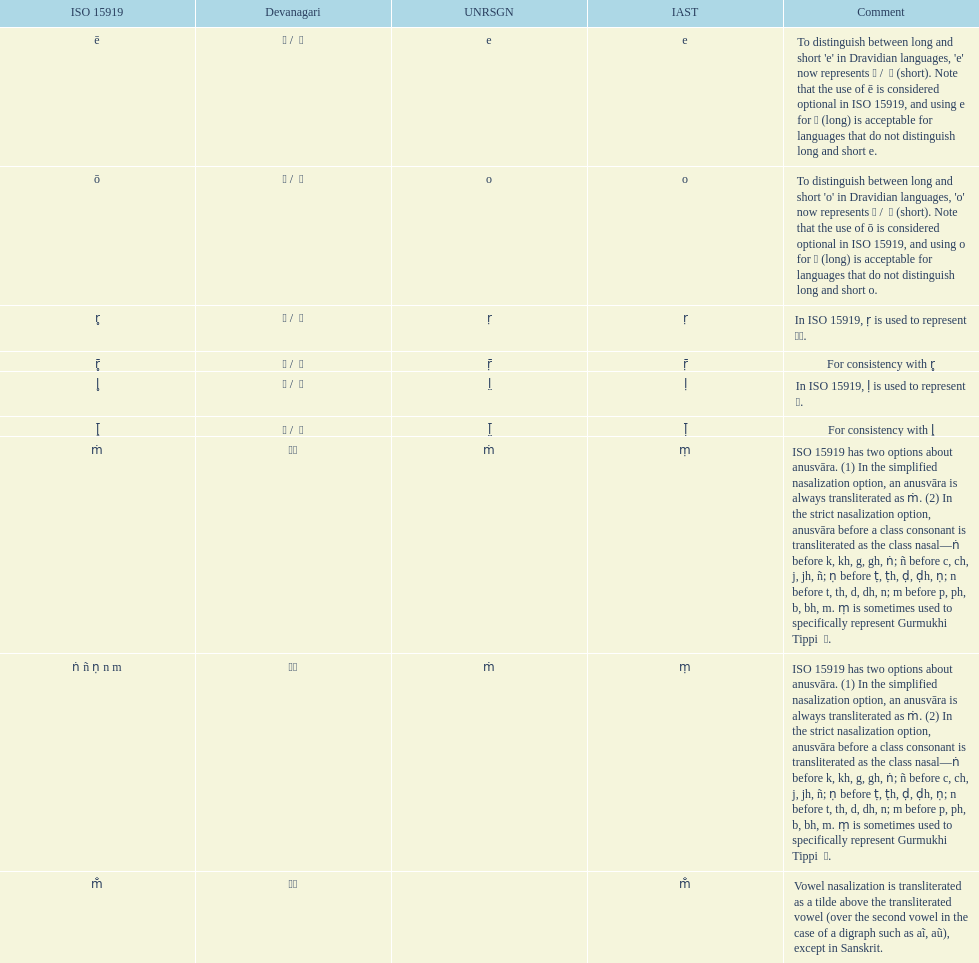Which devanagaria means the same as this iast letter: o? ओ / ो. 